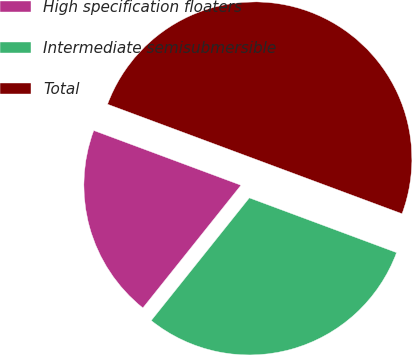<chart> <loc_0><loc_0><loc_500><loc_500><pie_chart><fcel>High specification floaters<fcel>Intermediate semisubmersible<fcel>Total<nl><fcel>19.93%<fcel>30.07%<fcel>50.0%<nl></chart> 